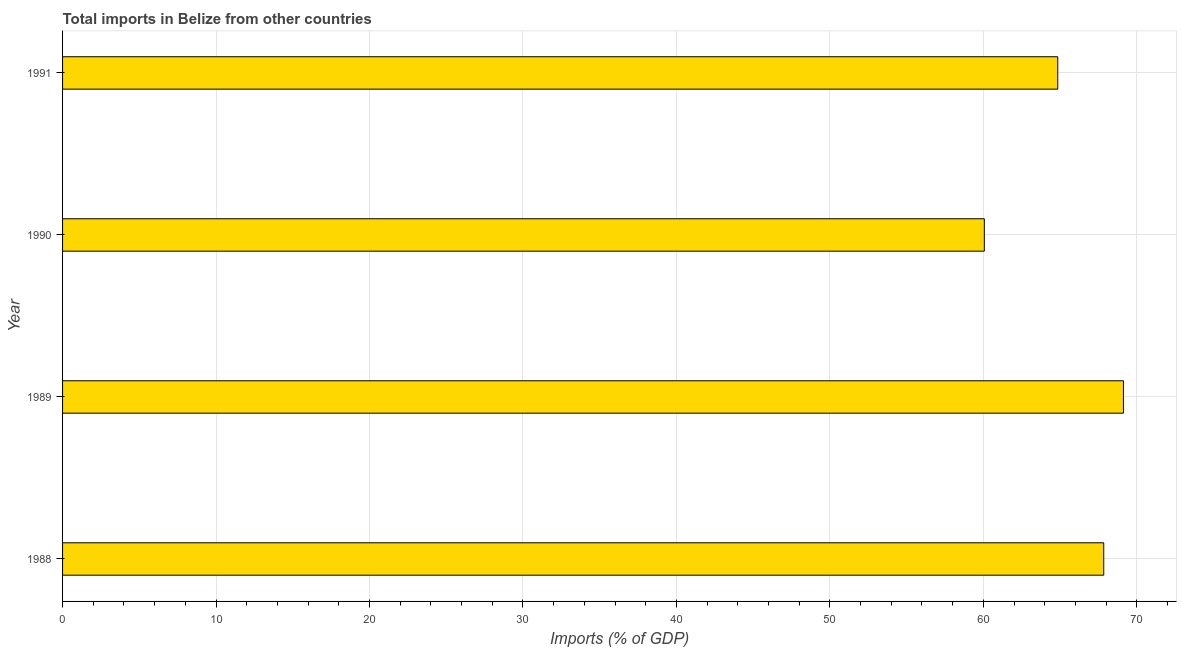Does the graph contain any zero values?
Provide a short and direct response. No. What is the title of the graph?
Your answer should be very brief. Total imports in Belize from other countries. What is the label or title of the X-axis?
Make the answer very short. Imports (% of GDP). What is the total imports in 1991?
Your answer should be very brief. 64.85. Across all years, what is the maximum total imports?
Keep it short and to the point. 69.13. Across all years, what is the minimum total imports?
Offer a very short reply. 60.07. What is the sum of the total imports?
Offer a terse response. 261.89. What is the difference between the total imports in 1989 and 1990?
Give a very brief answer. 9.07. What is the average total imports per year?
Provide a succinct answer. 65.47. What is the median total imports?
Offer a very short reply. 66.35. In how many years, is the total imports greater than 68 %?
Your answer should be compact. 1. What is the ratio of the total imports in 1989 to that in 1990?
Your response must be concise. 1.15. Is the difference between the total imports in 1990 and 1991 greater than the difference between any two years?
Provide a succinct answer. No. What is the difference between the highest and the second highest total imports?
Offer a terse response. 1.28. What is the difference between the highest and the lowest total imports?
Your response must be concise. 9.07. In how many years, is the total imports greater than the average total imports taken over all years?
Ensure brevity in your answer.  2. Are all the bars in the graph horizontal?
Ensure brevity in your answer.  Yes. Are the values on the major ticks of X-axis written in scientific E-notation?
Provide a succinct answer. No. What is the Imports (% of GDP) of 1988?
Ensure brevity in your answer.  67.85. What is the Imports (% of GDP) of 1989?
Offer a very short reply. 69.13. What is the Imports (% of GDP) in 1990?
Ensure brevity in your answer.  60.07. What is the Imports (% of GDP) in 1991?
Provide a succinct answer. 64.85. What is the difference between the Imports (% of GDP) in 1988 and 1989?
Your response must be concise. -1.28. What is the difference between the Imports (% of GDP) in 1988 and 1990?
Ensure brevity in your answer.  7.78. What is the difference between the Imports (% of GDP) in 1988 and 1991?
Provide a short and direct response. 3. What is the difference between the Imports (% of GDP) in 1989 and 1990?
Ensure brevity in your answer.  9.07. What is the difference between the Imports (% of GDP) in 1989 and 1991?
Keep it short and to the point. 4.28. What is the difference between the Imports (% of GDP) in 1990 and 1991?
Ensure brevity in your answer.  -4.78. What is the ratio of the Imports (% of GDP) in 1988 to that in 1990?
Keep it short and to the point. 1.13. What is the ratio of the Imports (% of GDP) in 1988 to that in 1991?
Your answer should be very brief. 1.05. What is the ratio of the Imports (% of GDP) in 1989 to that in 1990?
Make the answer very short. 1.15. What is the ratio of the Imports (% of GDP) in 1989 to that in 1991?
Offer a terse response. 1.07. What is the ratio of the Imports (% of GDP) in 1990 to that in 1991?
Keep it short and to the point. 0.93. 